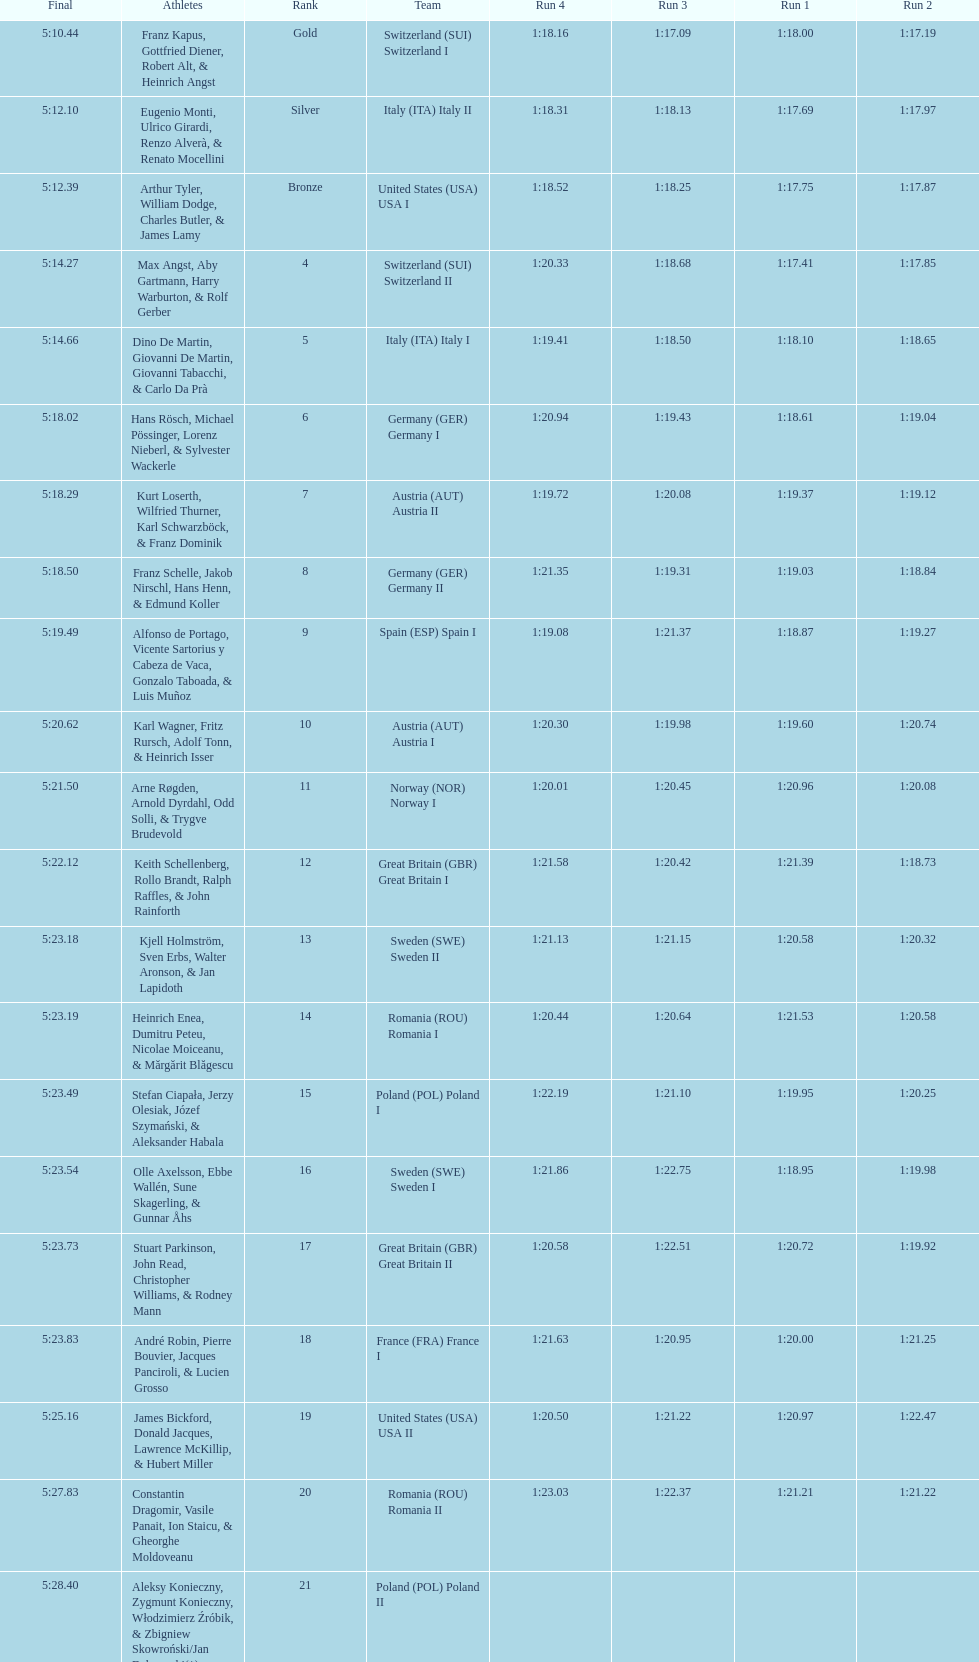Name a country that had 4 consecutive runs under 1:19. Switzerland. Could you parse the entire table? {'header': ['Final', 'Athletes', 'Rank', 'Team', 'Run 4', 'Run 3', 'Run 1', 'Run 2'], 'rows': [['5:10.44', 'Franz Kapus, Gottfried Diener, Robert Alt, & Heinrich Angst', 'Gold', 'Switzerland\xa0(SUI) Switzerland I', '1:18.16', '1:17.09', '1:18.00', '1:17.19'], ['5:12.10', 'Eugenio Monti, Ulrico Girardi, Renzo Alverà, & Renato Mocellini', 'Silver', 'Italy\xa0(ITA) Italy II', '1:18.31', '1:18.13', '1:17.69', '1:17.97'], ['5:12.39', 'Arthur Tyler, William Dodge, Charles Butler, & James Lamy', 'Bronze', 'United States\xa0(USA) USA I', '1:18.52', '1:18.25', '1:17.75', '1:17.87'], ['5:14.27', 'Max Angst, Aby Gartmann, Harry Warburton, & Rolf Gerber', '4', 'Switzerland\xa0(SUI) Switzerland II', '1:20.33', '1:18.68', '1:17.41', '1:17.85'], ['5:14.66', 'Dino De Martin, Giovanni De Martin, Giovanni Tabacchi, & Carlo Da Prà', '5', 'Italy\xa0(ITA) Italy I', '1:19.41', '1:18.50', '1:18.10', '1:18.65'], ['5:18.02', 'Hans Rösch, Michael Pössinger, Lorenz Nieberl, & Sylvester Wackerle', '6', 'Germany\xa0(GER) Germany I', '1:20.94', '1:19.43', '1:18.61', '1:19.04'], ['5:18.29', 'Kurt Loserth, Wilfried Thurner, Karl Schwarzböck, & Franz Dominik', '7', 'Austria\xa0(AUT) Austria II', '1:19.72', '1:20.08', '1:19.37', '1:19.12'], ['5:18.50', 'Franz Schelle, Jakob Nirschl, Hans Henn, & Edmund Koller', '8', 'Germany\xa0(GER) Germany II', '1:21.35', '1:19.31', '1:19.03', '1:18.84'], ['5:19.49', 'Alfonso de Portago, Vicente Sartorius y Cabeza de Vaca, Gonzalo Taboada, & Luis Muñoz', '9', 'Spain\xa0(ESP) Spain I', '1:19.08', '1:21.37', '1:18.87', '1:19.27'], ['5:20.62', 'Karl Wagner, Fritz Rursch, Adolf Tonn, & Heinrich Isser', '10', 'Austria\xa0(AUT) Austria I', '1:20.30', '1:19.98', '1:19.60', '1:20.74'], ['5:21.50', 'Arne Røgden, Arnold Dyrdahl, Odd Solli, & Trygve Brudevold', '11', 'Norway\xa0(NOR) Norway I', '1:20.01', '1:20.45', '1:20.96', '1:20.08'], ['5:22.12', 'Keith Schellenberg, Rollo Brandt, Ralph Raffles, & John Rainforth', '12', 'Great Britain\xa0(GBR) Great Britain I', '1:21.58', '1:20.42', '1:21.39', '1:18.73'], ['5:23.18', 'Kjell Holmström, Sven Erbs, Walter Aronson, & Jan Lapidoth', '13', 'Sweden\xa0(SWE) Sweden II', '1:21.13', '1:21.15', '1:20.58', '1:20.32'], ['5:23.19', 'Heinrich Enea, Dumitru Peteu, Nicolae Moiceanu, & Mărgărit Blăgescu', '14', 'Romania\xa0(ROU) Romania I', '1:20.44', '1:20.64', '1:21.53', '1:20.58'], ['5:23.49', 'Stefan Ciapała, Jerzy Olesiak, Józef Szymański, & Aleksander Habala', '15', 'Poland\xa0(POL) Poland I', '1:22.19', '1:21.10', '1:19.95', '1:20.25'], ['5:23.54', 'Olle Axelsson, Ebbe Wallén, Sune Skagerling, & Gunnar Åhs', '16', 'Sweden\xa0(SWE) Sweden I', '1:21.86', '1:22.75', '1:18.95', '1:19.98'], ['5:23.73', 'Stuart Parkinson, John Read, Christopher Williams, & Rodney Mann', '17', 'Great Britain\xa0(GBR) Great Britain II', '1:20.58', '1:22.51', '1:20.72', '1:19.92'], ['5:23.83', 'André Robin, Pierre Bouvier, Jacques Panciroli, & Lucien Grosso', '18', 'France\xa0(FRA) France I', '1:21.63', '1:20.95', '1:20.00', '1:21.25'], ['5:25.16', 'James Bickford, Donald Jacques, Lawrence McKillip, & Hubert Miller', '19', 'United States\xa0(USA) USA II', '1:20.50', '1:21.22', '1:20.97', '1:22.47'], ['5:27.83', 'Constantin Dragomir, Vasile Panait, Ion Staicu, & Gheorghe Moldoveanu', '20', 'Romania\xa0(ROU) Romania II', '1:23.03', '1:22.37', '1:21.21', '1:21.22'], ['5:28.40', 'Aleksy Konieczny, Zygmunt Konieczny, Włodzimierz Źróbik, & Zbigniew Skowroński/Jan Dąbrowski(*)', '21', 'Poland\xa0(POL) Poland II', '', '', '', '']]} 